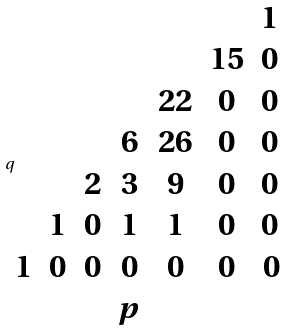<formula> <loc_0><loc_0><loc_500><loc_500>q \begin{matrix} & & & & & & 1 \, \\ & & & & & 1 5 & 0 \, \\ & & & & 2 2 & 0 & 0 \, \\ & & & 6 & 2 6 & 0 & 0 \, \\ & & 2 & 3 & 9 & 0 & 0 \, \\ & 1 & 0 & 1 & 1 & 0 & 0 \, \\ 1 & 0 & 0 & 0 & 0 & 0 & 0 \\ & & & p & & & \end{matrix}</formula> 